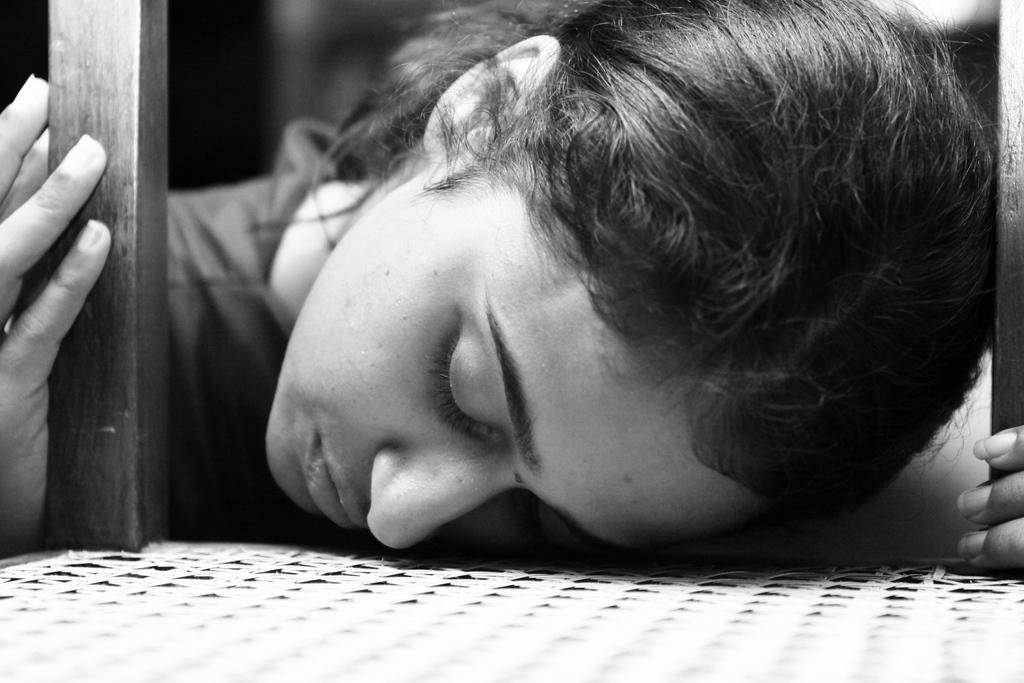In one or two sentences, can you explain what this image depicts? In this picture we can see a woman sleeping on the on the chair. Behind there is a blur background. 